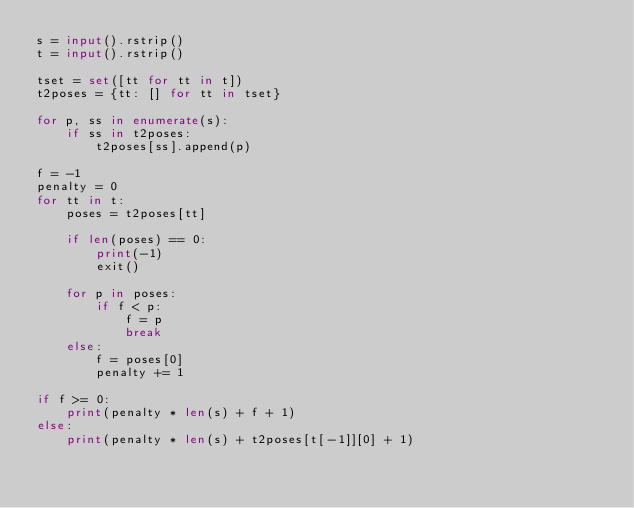<code> <loc_0><loc_0><loc_500><loc_500><_Python_>s = input().rstrip()
t = input().rstrip()

tset = set([tt for tt in t])
t2poses = {tt: [] for tt in tset}

for p, ss in enumerate(s):
    if ss in t2poses:
        t2poses[ss].append(p)

f = -1
penalty = 0
for tt in t:
    poses = t2poses[tt]

    if len(poses) == 0:
        print(-1)
        exit()

    for p in poses:
        if f < p:
            f = p
            break
    else:
        f = poses[0]
        penalty += 1

if f >= 0:
    print(penalty * len(s) + f + 1)
else:
    print(penalty * len(s) + t2poses[t[-1]][0] + 1)
</code> 